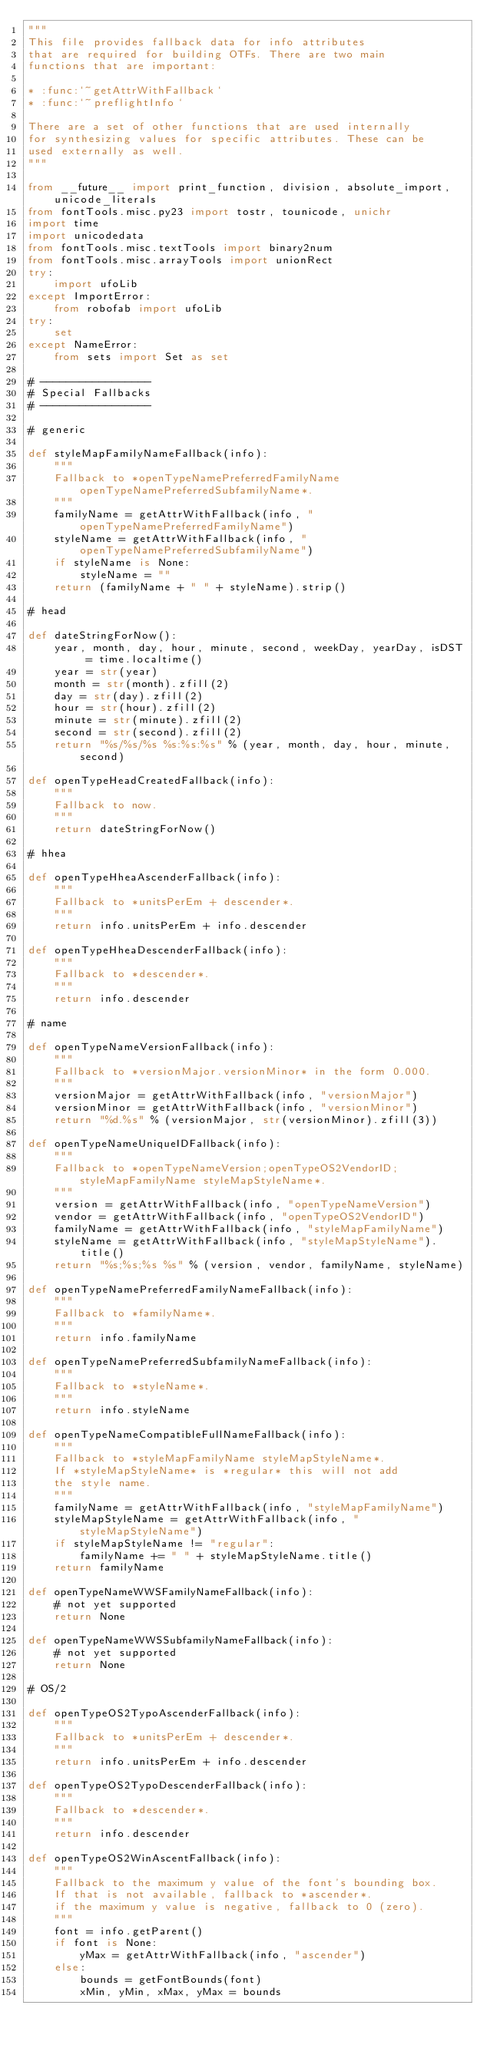Convert code to text. <code><loc_0><loc_0><loc_500><loc_500><_Python_>"""
This file provides fallback data for info attributes
that are required for building OTFs. There are two main
functions that are important:

* :func:`~getAttrWithFallback`
* :func:`~preflightInfo`

There are a set of other functions that are used internally
for synthesizing values for specific attributes. These can be
used externally as well.
"""

from __future__ import print_function, division, absolute_import, unicode_literals
from fontTools.misc.py23 import tostr, tounicode, unichr
import time
import unicodedata
from fontTools.misc.textTools import binary2num
from fontTools.misc.arrayTools import unionRect
try:
    import ufoLib
except ImportError:
    from robofab import ufoLib
try:
    set
except NameError:
    from sets import Set as set

# -----------------
# Special Fallbacks
# -----------------

# generic

def styleMapFamilyNameFallback(info):
    """
    Fallback to *openTypeNamePreferredFamilyName openTypeNamePreferredSubfamilyName*.
    """
    familyName = getAttrWithFallback(info, "openTypeNamePreferredFamilyName")
    styleName = getAttrWithFallback(info, "openTypeNamePreferredSubfamilyName")
    if styleName is None:
        styleName = ""
    return (familyName + " " + styleName).strip()

# head

def dateStringForNow():
    year, month, day, hour, minute, second, weekDay, yearDay, isDST = time.localtime()
    year = str(year)
    month = str(month).zfill(2)
    day = str(day).zfill(2)
    hour = str(hour).zfill(2)
    minute = str(minute).zfill(2)
    second = str(second).zfill(2)
    return "%s/%s/%s %s:%s:%s" % (year, month, day, hour, minute, second)

def openTypeHeadCreatedFallback(info):
    """
    Fallback to now.
    """
    return dateStringForNow()

# hhea

def openTypeHheaAscenderFallback(info):
    """
    Fallback to *unitsPerEm + descender*.
    """
    return info.unitsPerEm + info.descender

def openTypeHheaDescenderFallback(info):
    """
    Fallback to *descender*.
    """
    return info.descender

# name

def openTypeNameVersionFallback(info):
    """
    Fallback to *versionMajor.versionMinor* in the form 0.000.
    """
    versionMajor = getAttrWithFallback(info, "versionMajor")
    versionMinor = getAttrWithFallback(info, "versionMinor")
    return "%d.%s" % (versionMajor, str(versionMinor).zfill(3))

def openTypeNameUniqueIDFallback(info):
    """
    Fallback to *openTypeNameVersion;openTypeOS2VendorID;styleMapFamilyName styleMapStyleName*.
    """
    version = getAttrWithFallback(info, "openTypeNameVersion")
    vendor = getAttrWithFallback(info, "openTypeOS2VendorID")
    familyName = getAttrWithFallback(info, "styleMapFamilyName")
    styleName = getAttrWithFallback(info, "styleMapStyleName").title()
    return "%s;%s;%s %s" % (version, vendor, familyName, styleName)

def openTypeNamePreferredFamilyNameFallback(info):
    """
    Fallback to *familyName*.
    """
    return info.familyName

def openTypeNamePreferredSubfamilyNameFallback(info):
    """
    Fallback to *styleName*.
    """
    return info.styleName

def openTypeNameCompatibleFullNameFallback(info):
    """
    Fallback to *styleMapFamilyName styleMapStyleName*.
    If *styleMapStyleName* is *regular* this will not add
    the style name.
    """
    familyName = getAttrWithFallback(info, "styleMapFamilyName")
    styleMapStyleName = getAttrWithFallback(info, "styleMapStyleName")
    if styleMapStyleName != "regular":
        familyName += " " + styleMapStyleName.title()
    return familyName

def openTypeNameWWSFamilyNameFallback(info):
    # not yet supported
    return None

def openTypeNameWWSSubfamilyNameFallback(info):
    # not yet supported
    return None

# OS/2

def openTypeOS2TypoAscenderFallback(info):
    """
    Fallback to *unitsPerEm + descender*.
    """
    return info.unitsPerEm + info.descender

def openTypeOS2TypoDescenderFallback(info):
    """
    Fallback to *descender*.
    """
    return info.descender

def openTypeOS2WinAscentFallback(info):
    """
    Fallback to the maximum y value of the font's bounding box.
    If that is not available, fallback to *ascender*.
    if the maximum y value is negative, fallback to 0 (zero).
    """
    font = info.getParent()
    if font is None:
        yMax = getAttrWithFallback(info, "ascender")
    else:
        bounds = getFontBounds(font)
        xMin, yMin, xMax, yMax = bounds</code> 